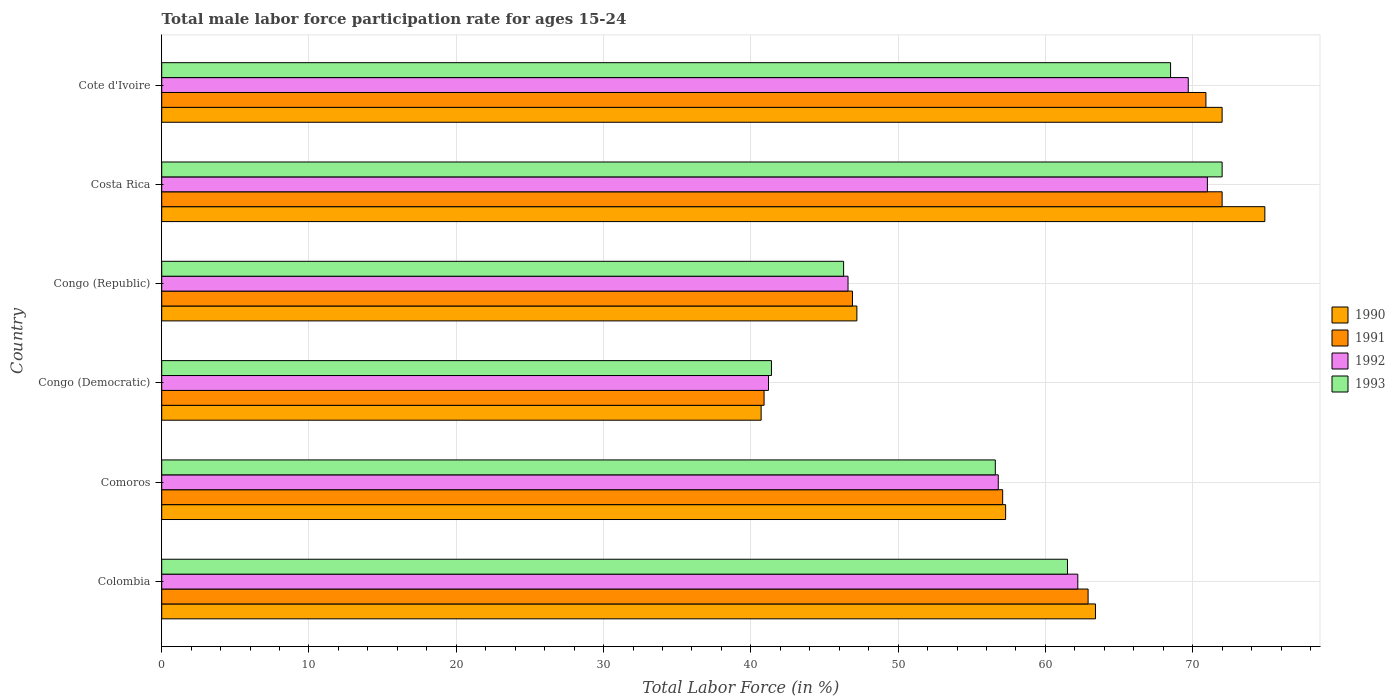Are the number of bars per tick equal to the number of legend labels?
Give a very brief answer. Yes. How many bars are there on the 4th tick from the top?
Make the answer very short. 4. What is the label of the 6th group of bars from the top?
Make the answer very short. Colombia. What is the male labor force participation rate in 1990 in Congo (Republic)?
Your answer should be compact. 47.2. Across all countries, what is the maximum male labor force participation rate in 1992?
Provide a short and direct response. 71. Across all countries, what is the minimum male labor force participation rate in 1991?
Offer a terse response. 40.9. In which country was the male labor force participation rate in 1991 maximum?
Give a very brief answer. Costa Rica. In which country was the male labor force participation rate in 1991 minimum?
Provide a short and direct response. Congo (Democratic). What is the total male labor force participation rate in 1993 in the graph?
Give a very brief answer. 346.3. What is the difference between the male labor force participation rate in 1990 in Colombia and that in Costa Rica?
Offer a very short reply. -11.5. What is the difference between the male labor force participation rate in 1992 in Congo (Republic) and the male labor force participation rate in 1991 in Costa Rica?
Provide a short and direct response. -25.4. What is the average male labor force participation rate in 1991 per country?
Offer a terse response. 58.45. What is the difference between the male labor force participation rate in 1990 and male labor force participation rate in 1992 in Congo (Republic)?
Your answer should be compact. 0.6. What is the ratio of the male labor force participation rate in 1991 in Comoros to that in Congo (Democratic)?
Your response must be concise. 1.4. Is the male labor force participation rate in 1993 in Colombia less than that in Congo (Democratic)?
Provide a succinct answer. No. What is the difference between the highest and the lowest male labor force participation rate in 1993?
Your response must be concise. 30.6. Is the sum of the male labor force participation rate in 1991 in Colombia and Comoros greater than the maximum male labor force participation rate in 1990 across all countries?
Give a very brief answer. Yes. Is it the case that in every country, the sum of the male labor force participation rate in 1991 and male labor force participation rate in 1993 is greater than the sum of male labor force participation rate in 1992 and male labor force participation rate in 1990?
Offer a terse response. No. What does the 4th bar from the top in Congo (Democratic) represents?
Offer a terse response. 1990. Is it the case that in every country, the sum of the male labor force participation rate in 1992 and male labor force participation rate in 1993 is greater than the male labor force participation rate in 1990?
Provide a succinct answer. Yes. Are all the bars in the graph horizontal?
Offer a very short reply. Yes. How many countries are there in the graph?
Ensure brevity in your answer.  6. What is the difference between two consecutive major ticks on the X-axis?
Your response must be concise. 10. Are the values on the major ticks of X-axis written in scientific E-notation?
Make the answer very short. No. Does the graph contain any zero values?
Your answer should be compact. No. How are the legend labels stacked?
Give a very brief answer. Vertical. What is the title of the graph?
Your response must be concise. Total male labor force participation rate for ages 15-24. What is the label or title of the X-axis?
Make the answer very short. Total Labor Force (in %). What is the Total Labor Force (in %) in 1990 in Colombia?
Your answer should be very brief. 63.4. What is the Total Labor Force (in %) in 1991 in Colombia?
Offer a terse response. 62.9. What is the Total Labor Force (in %) of 1992 in Colombia?
Your response must be concise. 62.2. What is the Total Labor Force (in %) of 1993 in Colombia?
Offer a very short reply. 61.5. What is the Total Labor Force (in %) of 1990 in Comoros?
Provide a succinct answer. 57.3. What is the Total Labor Force (in %) in 1991 in Comoros?
Ensure brevity in your answer.  57.1. What is the Total Labor Force (in %) of 1992 in Comoros?
Your answer should be compact. 56.8. What is the Total Labor Force (in %) of 1993 in Comoros?
Provide a succinct answer. 56.6. What is the Total Labor Force (in %) in 1990 in Congo (Democratic)?
Your response must be concise. 40.7. What is the Total Labor Force (in %) in 1991 in Congo (Democratic)?
Keep it short and to the point. 40.9. What is the Total Labor Force (in %) of 1992 in Congo (Democratic)?
Your response must be concise. 41.2. What is the Total Labor Force (in %) of 1993 in Congo (Democratic)?
Offer a terse response. 41.4. What is the Total Labor Force (in %) of 1990 in Congo (Republic)?
Ensure brevity in your answer.  47.2. What is the Total Labor Force (in %) in 1991 in Congo (Republic)?
Your answer should be compact. 46.9. What is the Total Labor Force (in %) of 1992 in Congo (Republic)?
Provide a short and direct response. 46.6. What is the Total Labor Force (in %) in 1993 in Congo (Republic)?
Provide a short and direct response. 46.3. What is the Total Labor Force (in %) of 1990 in Costa Rica?
Offer a terse response. 74.9. What is the Total Labor Force (in %) of 1991 in Costa Rica?
Ensure brevity in your answer.  72. What is the Total Labor Force (in %) of 1993 in Costa Rica?
Your response must be concise. 72. What is the Total Labor Force (in %) in 1990 in Cote d'Ivoire?
Offer a very short reply. 72. What is the Total Labor Force (in %) of 1991 in Cote d'Ivoire?
Your answer should be very brief. 70.9. What is the Total Labor Force (in %) of 1992 in Cote d'Ivoire?
Offer a very short reply. 69.7. What is the Total Labor Force (in %) in 1993 in Cote d'Ivoire?
Your answer should be very brief. 68.5. Across all countries, what is the maximum Total Labor Force (in %) in 1990?
Your answer should be very brief. 74.9. Across all countries, what is the maximum Total Labor Force (in %) of 1992?
Provide a short and direct response. 71. Across all countries, what is the minimum Total Labor Force (in %) of 1990?
Ensure brevity in your answer.  40.7. Across all countries, what is the minimum Total Labor Force (in %) of 1991?
Provide a succinct answer. 40.9. Across all countries, what is the minimum Total Labor Force (in %) in 1992?
Offer a very short reply. 41.2. Across all countries, what is the minimum Total Labor Force (in %) of 1993?
Provide a succinct answer. 41.4. What is the total Total Labor Force (in %) in 1990 in the graph?
Give a very brief answer. 355.5. What is the total Total Labor Force (in %) of 1991 in the graph?
Your response must be concise. 350.7. What is the total Total Labor Force (in %) in 1992 in the graph?
Provide a short and direct response. 347.5. What is the total Total Labor Force (in %) of 1993 in the graph?
Make the answer very short. 346.3. What is the difference between the Total Labor Force (in %) in 1990 in Colombia and that in Comoros?
Provide a short and direct response. 6.1. What is the difference between the Total Labor Force (in %) in 1991 in Colombia and that in Comoros?
Offer a very short reply. 5.8. What is the difference between the Total Labor Force (in %) of 1993 in Colombia and that in Comoros?
Provide a short and direct response. 4.9. What is the difference between the Total Labor Force (in %) of 1990 in Colombia and that in Congo (Democratic)?
Your response must be concise. 22.7. What is the difference between the Total Labor Force (in %) in 1993 in Colombia and that in Congo (Democratic)?
Give a very brief answer. 20.1. What is the difference between the Total Labor Force (in %) in 1992 in Colombia and that in Congo (Republic)?
Your answer should be compact. 15.6. What is the difference between the Total Labor Force (in %) of 1993 in Colombia and that in Congo (Republic)?
Provide a succinct answer. 15.2. What is the difference between the Total Labor Force (in %) in 1990 in Colombia and that in Costa Rica?
Your response must be concise. -11.5. What is the difference between the Total Labor Force (in %) in 1991 in Colombia and that in Costa Rica?
Give a very brief answer. -9.1. What is the difference between the Total Labor Force (in %) in 1993 in Colombia and that in Costa Rica?
Give a very brief answer. -10.5. What is the difference between the Total Labor Force (in %) of 1993 in Colombia and that in Cote d'Ivoire?
Your response must be concise. -7. What is the difference between the Total Labor Force (in %) in 1992 in Comoros and that in Congo (Democratic)?
Keep it short and to the point. 15.6. What is the difference between the Total Labor Force (in %) in 1993 in Comoros and that in Congo (Democratic)?
Give a very brief answer. 15.2. What is the difference between the Total Labor Force (in %) in 1992 in Comoros and that in Congo (Republic)?
Provide a succinct answer. 10.2. What is the difference between the Total Labor Force (in %) in 1990 in Comoros and that in Costa Rica?
Offer a very short reply. -17.6. What is the difference between the Total Labor Force (in %) of 1991 in Comoros and that in Costa Rica?
Provide a short and direct response. -14.9. What is the difference between the Total Labor Force (in %) in 1992 in Comoros and that in Costa Rica?
Your response must be concise. -14.2. What is the difference between the Total Labor Force (in %) of 1993 in Comoros and that in Costa Rica?
Your answer should be compact. -15.4. What is the difference between the Total Labor Force (in %) in 1990 in Comoros and that in Cote d'Ivoire?
Keep it short and to the point. -14.7. What is the difference between the Total Labor Force (in %) of 1992 in Comoros and that in Cote d'Ivoire?
Make the answer very short. -12.9. What is the difference between the Total Labor Force (in %) of 1993 in Congo (Democratic) and that in Congo (Republic)?
Ensure brevity in your answer.  -4.9. What is the difference between the Total Labor Force (in %) of 1990 in Congo (Democratic) and that in Costa Rica?
Provide a succinct answer. -34.2. What is the difference between the Total Labor Force (in %) of 1991 in Congo (Democratic) and that in Costa Rica?
Your answer should be compact. -31.1. What is the difference between the Total Labor Force (in %) in 1992 in Congo (Democratic) and that in Costa Rica?
Offer a terse response. -29.8. What is the difference between the Total Labor Force (in %) in 1993 in Congo (Democratic) and that in Costa Rica?
Ensure brevity in your answer.  -30.6. What is the difference between the Total Labor Force (in %) in 1990 in Congo (Democratic) and that in Cote d'Ivoire?
Your response must be concise. -31.3. What is the difference between the Total Labor Force (in %) in 1992 in Congo (Democratic) and that in Cote d'Ivoire?
Offer a terse response. -28.5. What is the difference between the Total Labor Force (in %) in 1993 in Congo (Democratic) and that in Cote d'Ivoire?
Your answer should be very brief. -27.1. What is the difference between the Total Labor Force (in %) of 1990 in Congo (Republic) and that in Costa Rica?
Give a very brief answer. -27.7. What is the difference between the Total Labor Force (in %) of 1991 in Congo (Republic) and that in Costa Rica?
Ensure brevity in your answer.  -25.1. What is the difference between the Total Labor Force (in %) of 1992 in Congo (Republic) and that in Costa Rica?
Offer a very short reply. -24.4. What is the difference between the Total Labor Force (in %) in 1993 in Congo (Republic) and that in Costa Rica?
Make the answer very short. -25.7. What is the difference between the Total Labor Force (in %) of 1990 in Congo (Republic) and that in Cote d'Ivoire?
Your response must be concise. -24.8. What is the difference between the Total Labor Force (in %) in 1992 in Congo (Republic) and that in Cote d'Ivoire?
Make the answer very short. -23.1. What is the difference between the Total Labor Force (in %) of 1993 in Congo (Republic) and that in Cote d'Ivoire?
Your answer should be very brief. -22.2. What is the difference between the Total Labor Force (in %) of 1990 in Costa Rica and that in Cote d'Ivoire?
Offer a very short reply. 2.9. What is the difference between the Total Labor Force (in %) of 1993 in Costa Rica and that in Cote d'Ivoire?
Ensure brevity in your answer.  3.5. What is the difference between the Total Labor Force (in %) in 1990 in Colombia and the Total Labor Force (in %) in 1991 in Comoros?
Your response must be concise. 6.3. What is the difference between the Total Labor Force (in %) of 1991 in Colombia and the Total Labor Force (in %) of 1992 in Comoros?
Offer a terse response. 6.1. What is the difference between the Total Labor Force (in %) in 1992 in Colombia and the Total Labor Force (in %) in 1993 in Comoros?
Your response must be concise. 5.6. What is the difference between the Total Labor Force (in %) of 1990 in Colombia and the Total Labor Force (in %) of 1993 in Congo (Democratic)?
Give a very brief answer. 22. What is the difference between the Total Labor Force (in %) in 1991 in Colombia and the Total Labor Force (in %) in 1992 in Congo (Democratic)?
Your answer should be very brief. 21.7. What is the difference between the Total Labor Force (in %) of 1992 in Colombia and the Total Labor Force (in %) of 1993 in Congo (Democratic)?
Make the answer very short. 20.8. What is the difference between the Total Labor Force (in %) in 1990 in Colombia and the Total Labor Force (in %) in 1991 in Congo (Republic)?
Give a very brief answer. 16.5. What is the difference between the Total Labor Force (in %) of 1990 in Colombia and the Total Labor Force (in %) of 1992 in Congo (Republic)?
Provide a short and direct response. 16.8. What is the difference between the Total Labor Force (in %) in 1990 in Colombia and the Total Labor Force (in %) in 1993 in Congo (Republic)?
Your answer should be very brief. 17.1. What is the difference between the Total Labor Force (in %) of 1991 in Colombia and the Total Labor Force (in %) of 1992 in Congo (Republic)?
Your answer should be compact. 16.3. What is the difference between the Total Labor Force (in %) in 1991 in Colombia and the Total Labor Force (in %) in 1993 in Congo (Republic)?
Ensure brevity in your answer.  16.6. What is the difference between the Total Labor Force (in %) in 1990 in Colombia and the Total Labor Force (in %) in 1991 in Costa Rica?
Make the answer very short. -8.6. What is the difference between the Total Labor Force (in %) of 1990 in Colombia and the Total Labor Force (in %) of 1992 in Costa Rica?
Your answer should be very brief. -7.6. What is the difference between the Total Labor Force (in %) of 1992 in Colombia and the Total Labor Force (in %) of 1993 in Costa Rica?
Your answer should be very brief. -9.8. What is the difference between the Total Labor Force (in %) of 1990 in Colombia and the Total Labor Force (in %) of 1991 in Cote d'Ivoire?
Provide a succinct answer. -7.5. What is the difference between the Total Labor Force (in %) in 1990 in Colombia and the Total Labor Force (in %) in 1992 in Cote d'Ivoire?
Ensure brevity in your answer.  -6.3. What is the difference between the Total Labor Force (in %) of 1990 in Colombia and the Total Labor Force (in %) of 1993 in Cote d'Ivoire?
Provide a short and direct response. -5.1. What is the difference between the Total Labor Force (in %) in 1992 in Colombia and the Total Labor Force (in %) in 1993 in Cote d'Ivoire?
Offer a terse response. -6.3. What is the difference between the Total Labor Force (in %) of 1990 in Comoros and the Total Labor Force (in %) of 1993 in Congo (Democratic)?
Offer a terse response. 15.9. What is the difference between the Total Labor Force (in %) in 1992 in Comoros and the Total Labor Force (in %) in 1993 in Congo (Republic)?
Your answer should be very brief. 10.5. What is the difference between the Total Labor Force (in %) of 1990 in Comoros and the Total Labor Force (in %) of 1991 in Costa Rica?
Your answer should be compact. -14.7. What is the difference between the Total Labor Force (in %) in 1990 in Comoros and the Total Labor Force (in %) in 1992 in Costa Rica?
Your answer should be compact. -13.7. What is the difference between the Total Labor Force (in %) in 1990 in Comoros and the Total Labor Force (in %) in 1993 in Costa Rica?
Offer a very short reply. -14.7. What is the difference between the Total Labor Force (in %) of 1991 in Comoros and the Total Labor Force (in %) of 1992 in Costa Rica?
Keep it short and to the point. -13.9. What is the difference between the Total Labor Force (in %) of 1991 in Comoros and the Total Labor Force (in %) of 1993 in Costa Rica?
Offer a terse response. -14.9. What is the difference between the Total Labor Force (in %) of 1992 in Comoros and the Total Labor Force (in %) of 1993 in Costa Rica?
Offer a very short reply. -15.2. What is the difference between the Total Labor Force (in %) in 1990 in Comoros and the Total Labor Force (in %) in 1991 in Cote d'Ivoire?
Make the answer very short. -13.6. What is the difference between the Total Labor Force (in %) in 1990 in Comoros and the Total Labor Force (in %) in 1992 in Cote d'Ivoire?
Offer a very short reply. -12.4. What is the difference between the Total Labor Force (in %) in 1992 in Comoros and the Total Labor Force (in %) in 1993 in Cote d'Ivoire?
Provide a short and direct response. -11.7. What is the difference between the Total Labor Force (in %) in 1990 in Congo (Democratic) and the Total Labor Force (in %) in 1991 in Congo (Republic)?
Make the answer very short. -6.2. What is the difference between the Total Labor Force (in %) of 1991 in Congo (Democratic) and the Total Labor Force (in %) of 1992 in Congo (Republic)?
Provide a short and direct response. -5.7. What is the difference between the Total Labor Force (in %) in 1990 in Congo (Democratic) and the Total Labor Force (in %) in 1991 in Costa Rica?
Offer a very short reply. -31.3. What is the difference between the Total Labor Force (in %) in 1990 in Congo (Democratic) and the Total Labor Force (in %) in 1992 in Costa Rica?
Your response must be concise. -30.3. What is the difference between the Total Labor Force (in %) of 1990 in Congo (Democratic) and the Total Labor Force (in %) of 1993 in Costa Rica?
Your answer should be compact. -31.3. What is the difference between the Total Labor Force (in %) in 1991 in Congo (Democratic) and the Total Labor Force (in %) in 1992 in Costa Rica?
Give a very brief answer. -30.1. What is the difference between the Total Labor Force (in %) of 1991 in Congo (Democratic) and the Total Labor Force (in %) of 1993 in Costa Rica?
Your answer should be compact. -31.1. What is the difference between the Total Labor Force (in %) of 1992 in Congo (Democratic) and the Total Labor Force (in %) of 1993 in Costa Rica?
Your response must be concise. -30.8. What is the difference between the Total Labor Force (in %) in 1990 in Congo (Democratic) and the Total Labor Force (in %) in 1991 in Cote d'Ivoire?
Your answer should be very brief. -30.2. What is the difference between the Total Labor Force (in %) in 1990 in Congo (Democratic) and the Total Labor Force (in %) in 1992 in Cote d'Ivoire?
Offer a very short reply. -29. What is the difference between the Total Labor Force (in %) in 1990 in Congo (Democratic) and the Total Labor Force (in %) in 1993 in Cote d'Ivoire?
Ensure brevity in your answer.  -27.8. What is the difference between the Total Labor Force (in %) of 1991 in Congo (Democratic) and the Total Labor Force (in %) of 1992 in Cote d'Ivoire?
Offer a terse response. -28.8. What is the difference between the Total Labor Force (in %) in 1991 in Congo (Democratic) and the Total Labor Force (in %) in 1993 in Cote d'Ivoire?
Your response must be concise. -27.6. What is the difference between the Total Labor Force (in %) of 1992 in Congo (Democratic) and the Total Labor Force (in %) of 1993 in Cote d'Ivoire?
Provide a succinct answer. -27.3. What is the difference between the Total Labor Force (in %) in 1990 in Congo (Republic) and the Total Labor Force (in %) in 1991 in Costa Rica?
Provide a succinct answer. -24.8. What is the difference between the Total Labor Force (in %) of 1990 in Congo (Republic) and the Total Labor Force (in %) of 1992 in Costa Rica?
Give a very brief answer. -23.8. What is the difference between the Total Labor Force (in %) of 1990 in Congo (Republic) and the Total Labor Force (in %) of 1993 in Costa Rica?
Your response must be concise. -24.8. What is the difference between the Total Labor Force (in %) in 1991 in Congo (Republic) and the Total Labor Force (in %) in 1992 in Costa Rica?
Offer a terse response. -24.1. What is the difference between the Total Labor Force (in %) of 1991 in Congo (Republic) and the Total Labor Force (in %) of 1993 in Costa Rica?
Make the answer very short. -25.1. What is the difference between the Total Labor Force (in %) in 1992 in Congo (Republic) and the Total Labor Force (in %) in 1993 in Costa Rica?
Offer a very short reply. -25.4. What is the difference between the Total Labor Force (in %) of 1990 in Congo (Republic) and the Total Labor Force (in %) of 1991 in Cote d'Ivoire?
Provide a short and direct response. -23.7. What is the difference between the Total Labor Force (in %) in 1990 in Congo (Republic) and the Total Labor Force (in %) in 1992 in Cote d'Ivoire?
Offer a terse response. -22.5. What is the difference between the Total Labor Force (in %) in 1990 in Congo (Republic) and the Total Labor Force (in %) in 1993 in Cote d'Ivoire?
Provide a succinct answer. -21.3. What is the difference between the Total Labor Force (in %) of 1991 in Congo (Republic) and the Total Labor Force (in %) of 1992 in Cote d'Ivoire?
Ensure brevity in your answer.  -22.8. What is the difference between the Total Labor Force (in %) of 1991 in Congo (Republic) and the Total Labor Force (in %) of 1993 in Cote d'Ivoire?
Your response must be concise. -21.6. What is the difference between the Total Labor Force (in %) in 1992 in Congo (Republic) and the Total Labor Force (in %) in 1993 in Cote d'Ivoire?
Ensure brevity in your answer.  -21.9. What is the difference between the Total Labor Force (in %) in 1990 in Costa Rica and the Total Labor Force (in %) in 1991 in Cote d'Ivoire?
Offer a terse response. 4. What is the difference between the Total Labor Force (in %) in 1991 in Costa Rica and the Total Labor Force (in %) in 1993 in Cote d'Ivoire?
Your answer should be very brief. 3.5. What is the difference between the Total Labor Force (in %) of 1992 in Costa Rica and the Total Labor Force (in %) of 1993 in Cote d'Ivoire?
Your response must be concise. 2.5. What is the average Total Labor Force (in %) in 1990 per country?
Ensure brevity in your answer.  59.25. What is the average Total Labor Force (in %) of 1991 per country?
Provide a succinct answer. 58.45. What is the average Total Labor Force (in %) in 1992 per country?
Keep it short and to the point. 57.92. What is the average Total Labor Force (in %) of 1993 per country?
Make the answer very short. 57.72. What is the difference between the Total Labor Force (in %) in 1990 and Total Labor Force (in %) in 1991 in Colombia?
Give a very brief answer. 0.5. What is the difference between the Total Labor Force (in %) in 1990 and Total Labor Force (in %) in 1993 in Colombia?
Offer a very short reply. 1.9. What is the difference between the Total Labor Force (in %) in 1991 and Total Labor Force (in %) in 1992 in Colombia?
Make the answer very short. 0.7. What is the difference between the Total Labor Force (in %) in 1992 and Total Labor Force (in %) in 1993 in Colombia?
Your answer should be very brief. 0.7. What is the difference between the Total Labor Force (in %) in 1990 and Total Labor Force (in %) in 1991 in Comoros?
Make the answer very short. 0.2. What is the difference between the Total Labor Force (in %) in 1991 and Total Labor Force (in %) in 1992 in Comoros?
Your response must be concise. 0.3. What is the difference between the Total Labor Force (in %) of 1990 and Total Labor Force (in %) of 1992 in Congo (Democratic)?
Give a very brief answer. -0.5. What is the difference between the Total Labor Force (in %) of 1990 and Total Labor Force (in %) of 1993 in Congo (Democratic)?
Make the answer very short. -0.7. What is the difference between the Total Labor Force (in %) in 1991 and Total Labor Force (in %) in 1993 in Congo (Democratic)?
Your answer should be very brief. -0.5. What is the difference between the Total Labor Force (in %) of 1992 and Total Labor Force (in %) of 1993 in Congo (Democratic)?
Offer a terse response. -0.2. What is the difference between the Total Labor Force (in %) in 1990 and Total Labor Force (in %) in 1993 in Congo (Republic)?
Offer a very short reply. 0.9. What is the difference between the Total Labor Force (in %) of 1991 and Total Labor Force (in %) of 1992 in Congo (Republic)?
Give a very brief answer. 0.3. What is the difference between the Total Labor Force (in %) of 1991 and Total Labor Force (in %) of 1993 in Congo (Republic)?
Your answer should be very brief. 0.6. What is the difference between the Total Labor Force (in %) of 1990 and Total Labor Force (in %) of 1993 in Costa Rica?
Provide a short and direct response. 2.9. What is the difference between the Total Labor Force (in %) of 1991 and Total Labor Force (in %) of 1992 in Costa Rica?
Your response must be concise. 1. What is the difference between the Total Labor Force (in %) of 1991 and Total Labor Force (in %) of 1993 in Costa Rica?
Offer a terse response. 0. What is the difference between the Total Labor Force (in %) in 1990 and Total Labor Force (in %) in 1991 in Cote d'Ivoire?
Offer a very short reply. 1.1. What is the difference between the Total Labor Force (in %) in 1990 and Total Labor Force (in %) in 1993 in Cote d'Ivoire?
Ensure brevity in your answer.  3.5. What is the difference between the Total Labor Force (in %) in 1991 and Total Labor Force (in %) in 1993 in Cote d'Ivoire?
Provide a succinct answer. 2.4. What is the ratio of the Total Labor Force (in %) in 1990 in Colombia to that in Comoros?
Give a very brief answer. 1.11. What is the ratio of the Total Labor Force (in %) in 1991 in Colombia to that in Comoros?
Give a very brief answer. 1.1. What is the ratio of the Total Labor Force (in %) of 1992 in Colombia to that in Comoros?
Provide a short and direct response. 1.1. What is the ratio of the Total Labor Force (in %) in 1993 in Colombia to that in Comoros?
Give a very brief answer. 1.09. What is the ratio of the Total Labor Force (in %) of 1990 in Colombia to that in Congo (Democratic)?
Give a very brief answer. 1.56. What is the ratio of the Total Labor Force (in %) in 1991 in Colombia to that in Congo (Democratic)?
Provide a succinct answer. 1.54. What is the ratio of the Total Labor Force (in %) in 1992 in Colombia to that in Congo (Democratic)?
Keep it short and to the point. 1.51. What is the ratio of the Total Labor Force (in %) in 1993 in Colombia to that in Congo (Democratic)?
Your answer should be very brief. 1.49. What is the ratio of the Total Labor Force (in %) in 1990 in Colombia to that in Congo (Republic)?
Your answer should be compact. 1.34. What is the ratio of the Total Labor Force (in %) in 1991 in Colombia to that in Congo (Republic)?
Give a very brief answer. 1.34. What is the ratio of the Total Labor Force (in %) in 1992 in Colombia to that in Congo (Republic)?
Keep it short and to the point. 1.33. What is the ratio of the Total Labor Force (in %) in 1993 in Colombia to that in Congo (Republic)?
Your response must be concise. 1.33. What is the ratio of the Total Labor Force (in %) in 1990 in Colombia to that in Costa Rica?
Offer a very short reply. 0.85. What is the ratio of the Total Labor Force (in %) of 1991 in Colombia to that in Costa Rica?
Your response must be concise. 0.87. What is the ratio of the Total Labor Force (in %) in 1992 in Colombia to that in Costa Rica?
Provide a succinct answer. 0.88. What is the ratio of the Total Labor Force (in %) of 1993 in Colombia to that in Costa Rica?
Provide a succinct answer. 0.85. What is the ratio of the Total Labor Force (in %) of 1990 in Colombia to that in Cote d'Ivoire?
Make the answer very short. 0.88. What is the ratio of the Total Labor Force (in %) in 1991 in Colombia to that in Cote d'Ivoire?
Keep it short and to the point. 0.89. What is the ratio of the Total Labor Force (in %) of 1992 in Colombia to that in Cote d'Ivoire?
Provide a short and direct response. 0.89. What is the ratio of the Total Labor Force (in %) of 1993 in Colombia to that in Cote d'Ivoire?
Provide a succinct answer. 0.9. What is the ratio of the Total Labor Force (in %) of 1990 in Comoros to that in Congo (Democratic)?
Ensure brevity in your answer.  1.41. What is the ratio of the Total Labor Force (in %) of 1991 in Comoros to that in Congo (Democratic)?
Ensure brevity in your answer.  1.4. What is the ratio of the Total Labor Force (in %) of 1992 in Comoros to that in Congo (Democratic)?
Provide a short and direct response. 1.38. What is the ratio of the Total Labor Force (in %) of 1993 in Comoros to that in Congo (Democratic)?
Provide a short and direct response. 1.37. What is the ratio of the Total Labor Force (in %) of 1990 in Comoros to that in Congo (Republic)?
Provide a succinct answer. 1.21. What is the ratio of the Total Labor Force (in %) of 1991 in Comoros to that in Congo (Republic)?
Provide a short and direct response. 1.22. What is the ratio of the Total Labor Force (in %) of 1992 in Comoros to that in Congo (Republic)?
Your response must be concise. 1.22. What is the ratio of the Total Labor Force (in %) of 1993 in Comoros to that in Congo (Republic)?
Make the answer very short. 1.22. What is the ratio of the Total Labor Force (in %) in 1990 in Comoros to that in Costa Rica?
Your response must be concise. 0.77. What is the ratio of the Total Labor Force (in %) of 1991 in Comoros to that in Costa Rica?
Your answer should be compact. 0.79. What is the ratio of the Total Labor Force (in %) of 1993 in Comoros to that in Costa Rica?
Offer a terse response. 0.79. What is the ratio of the Total Labor Force (in %) of 1990 in Comoros to that in Cote d'Ivoire?
Keep it short and to the point. 0.8. What is the ratio of the Total Labor Force (in %) in 1991 in Comoros to that in Cote d'Ivoire?
Keep it short and to the point. 0.81. What is the ratio of the Total Labor Force (in %) in 1992 in Comoros to that in Cote d'Ivoire?
Provide a succinct answer. 0.81. What is the ratio of the Total Labor Force (in %) of 1993 in Comoros to that in Cote d'Ivoire?
Your answer should be compact. 0.83. What is the ratio of the Total Labor Force (in %) in 1990 in Congo (Democratic) to that in Congo (Republic)?
Your response must be concise. 0.86. What is the ratio of the Total Labor Force (in %) in 1991 in Congo (Democratic) to that in Congo (Republic)?
Ensure brevity in your answer.  0.87. What is the ratio of the Total Labor Force (in %) in 1992 in Congo (Democratic) to that in Congo (Republic)?
Ensure brevity in your answer.  0.88. What is the ratio of the Total Labor Force (in %) of 1993 in Congo (Democratic) to that in Congo (Republic)?
Your answer should be very brief. 0.89. What is the ratio of the Total Labor Force (in %) of 1990 in Congo (Democratic) to that in Costa Rica?
Make the answer very short. 0.54. What is the ratio of the Total Labor Force (in %) of 1991 in Congo (Democratic) to that in Costa Rica?
Give a very brief answer. 0.57. What is the ratio of the Total Labor Force (in %) in 1992 in Congo (Democratic) to that in Costa Rica?
Your response must be concise. 0.58. What is the ratio of the Total Labor Force (in %) in 1993 in Congo (Democratic) to that in Costa Rica?
Your answer should be compact. 0.57. What is the ratio of the Total Labor Force (in %) of 1990 in Congo (Democratic) to that in Cote d'Ivoire?
Your response must be concise. 0.57. What is the ratio of the Total Labor Force (in %) of 1991 in Congo (Democratic) to that in Cote d'Ivoire?
Provide a succinct answer. 0.58. What is the ratio of the Total Labor Force (in %) of 1992 in Congo (Democratic) to that in Cote d'Ivoire?
Your response must be concise. 0.59. What is the ratio of the Total Labor Force (in %) of 1993 in Congo (Democratic) to that in Cote d'Ivoire?
Offer a very short reply. 0.6. What is the ratio of the Total Labor Force (in %) in 1990 in Congo (Republic) to that in Costa Rica?
Ensure brevity in your answer.  0.63. What is the ratio of the Total Labor Force (in %) in 1991 in Congo (Republic) to that in Costa Rica?
Offer a terse response. 0.65. What is the ratio of the Total Labor Force (in %) of 1992 in Congo (Republic) to that in Costa Rica?
Offer a terse response. 0.66. What is the ratio of the Total Labor Force (in %) in 1993 in Congo (Republic) to that in Costa Rica?
Your response must be concise. 0.64. What is the ratio of the Total Labor Force (in %) in 1990 in Congo (Republic) to that in Cote d'Ivoire?
Ensure brevity in your answer.  0.66. What is the ratio of the Total Labor Force (in %) of 1991 in Congo (Republic) to that in Cote d'Ivoire?
Make the answer very short. 0.66. What is the ratio of the Total Labor Force (in %) of 1992 in Congo (Republic) to that in Cote d'Ivoire?
Ensure brevity in your answer.  0.67. What is the ratio of the Total Labor Force (in %) in 1993 in Congo (Republic) to that in Cote d'Ivoire?
Offer a terse response. 0.68. What is the ratio of the Total Labor Force (in %) in 1990 in Costa Rica to that in Cote d'Ivoire?
Keep it short and to the point. 1.04. What is the ratio of the Total Labor Force (in %) in 1991 in Costa Rica to that in Cote d'Ivoire?
Give a very brief answer. 1.02. What is the ratio of the Total Labor Force (in %) of 1992 in Costa Rica to that in Cote d'Ivoire?
Offer a terse response. 1.02. What is the ratio of the Total Labor Force (in %) in 1993 in Costa Rica to that in Cote d'Ivoire?
Offer a very short reply. 1.05. What is the difference between the highest and the second highest Total Labor Force (in %) of 1991?
Keep it short and to the point. 1.1. What is the difference between the highest and the second highest Total Labor Force (in %) of 1993?
Offer a very short reply. 3.5. What is the difference between the highest and the lowest Total Labor Force (in %) in 1990?
Offer a terse response. 34.2. What is the difference between the highest and the lowest Total Labor Force (in %) of 1991?
Your response must be concise. 31.1. What is the difference between the highest and the lowest Total Labor Force (in %) in 1992?
Give a very brief answer. 29.8. What is the difference between the highest and the lowest Total Labor Force (in %) in 1993?
Provide a short and direct response. 30.6. 